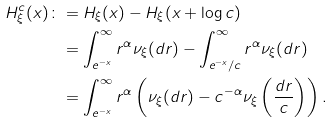Convert formula to latex. <formula><loc_0><loc_0><loc_500><loc_500>H ^ { c } _ { \xi } ( x ) \colon & = H _ { \xi } ( x ) - H _ { \xi } ( x + \log c ) \\ & = \int _ { e ^ { - x } } ^ { \infty } r ^ { \alpha } \nu _ { \xi } ( d r ) - \int _ { e ^ { - x } / c } ^ { \infty } r ^ { \alpha } \nu _ { \xi } ( d r ) \\ & = \int _ { e ^ { - x } } ^ { \infty } r ^ { \alpha } \left ( \nu _ { \xi } ( d r ) - c ^ { - \alpha } \nu _ { \xi } \left ( \frac { d r } { c } \right ) \right ) .</formula> 